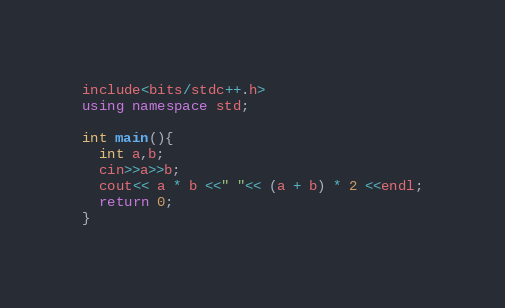Convert code to text. <code><loc_0><loc_0><loc_500><loc_500><_C++_>include<bits/stdc++.h>
using namespace std;

int main(){
  int a,b;
  cin>>a>>b;
  cout<< a * b <<" "<< (a + b) * 2 <<endl;
  return 0;
}
</code> 